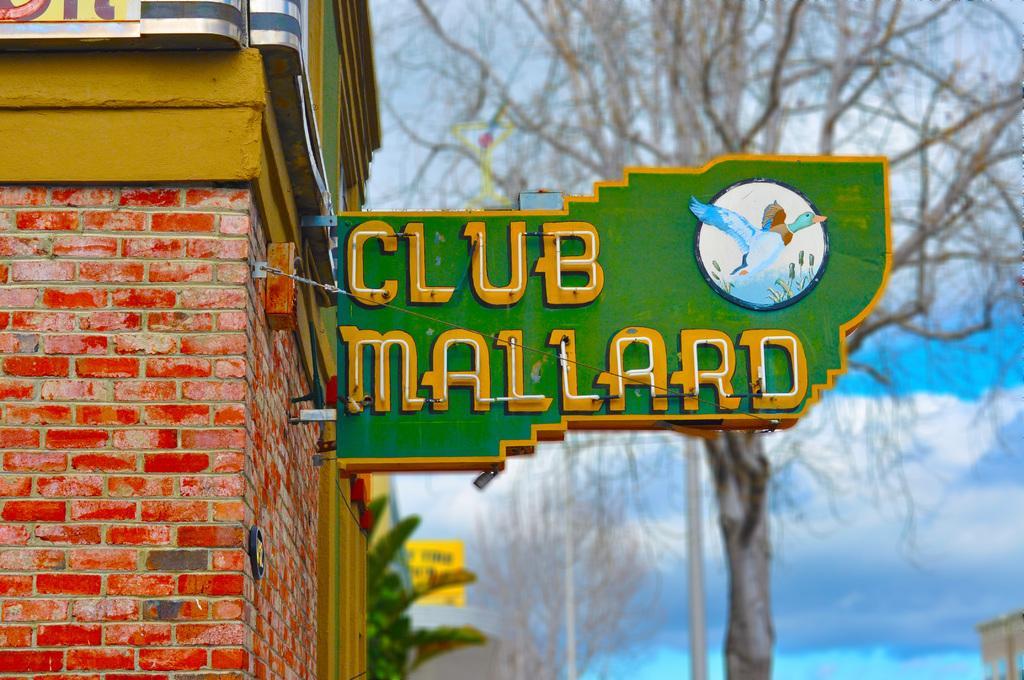Could you give a brief overview of what you see in this image? In this image we can see a building, there is the name board, there is the wall, there is the tree, at above here is the sky in blue color. 